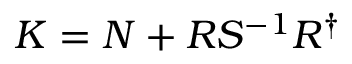Convert formula to latex. <formula><loc_0><loc_0><loc_500><loc_500>K = N + R S ^ { - 1 } R ^ { \dagger }</formula> 